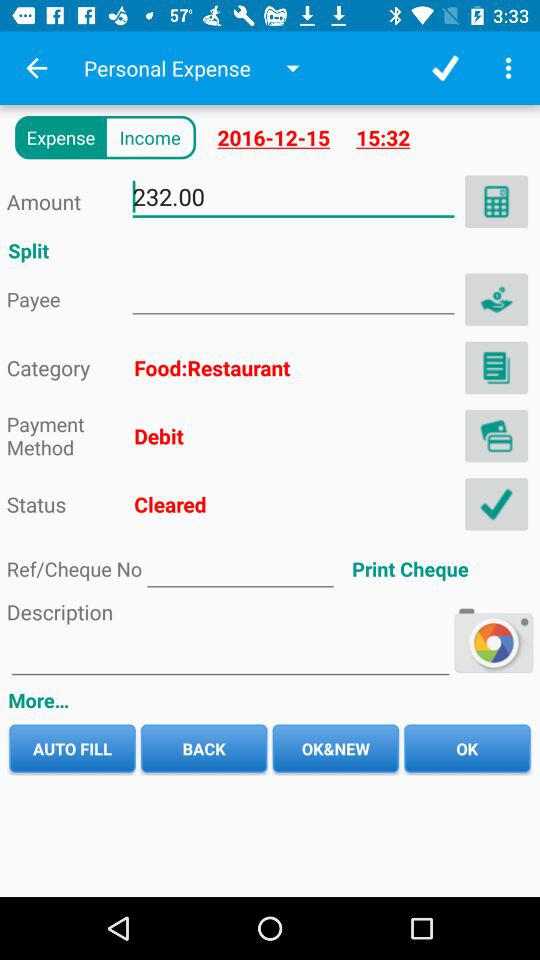What is the amount? The amount is 232. 